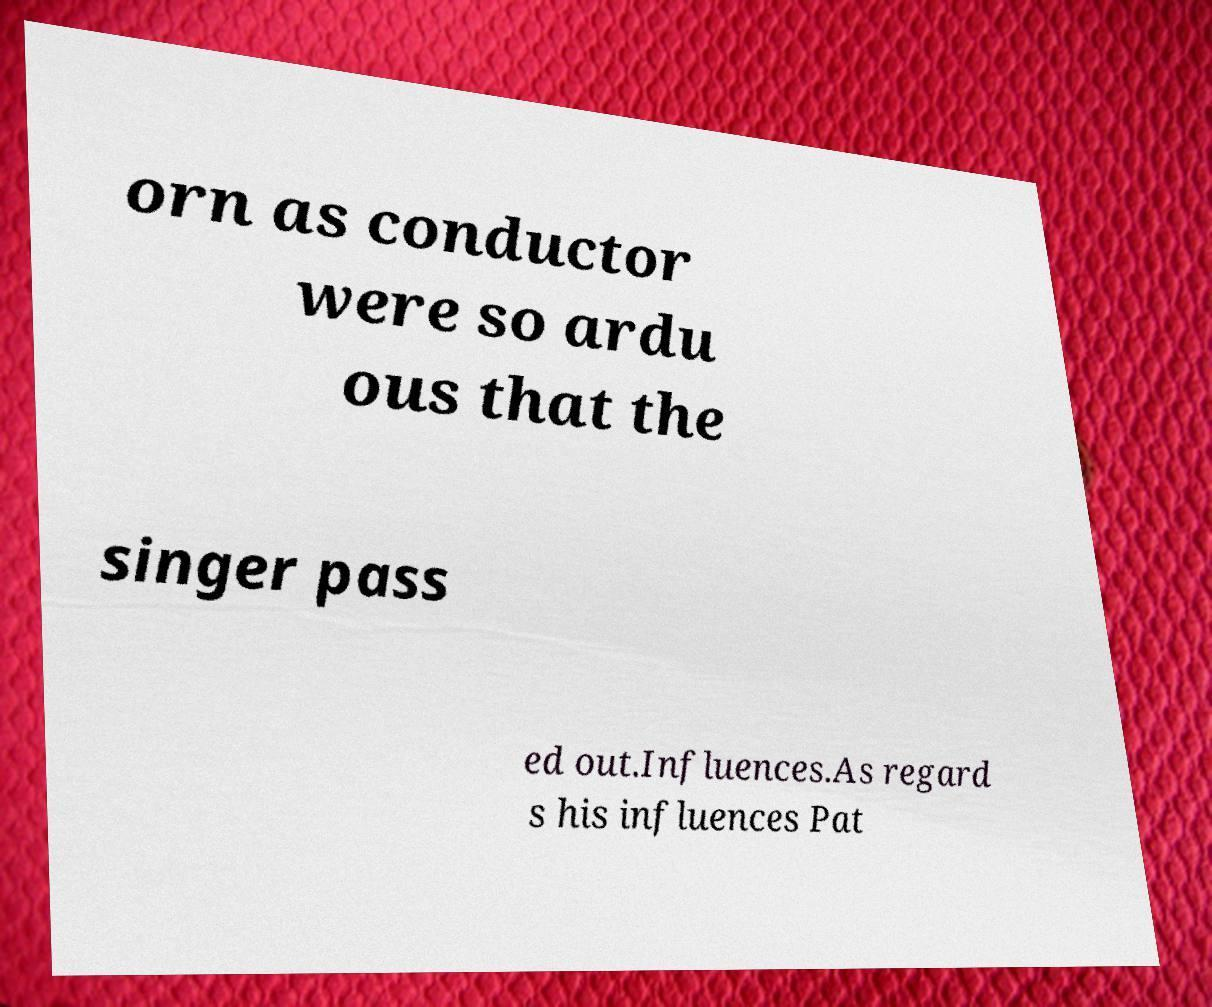Can you read and provide the text displayed in the image?This photo seems to have some interesting text. Can you extract and type it out for me? orn as conductor were so ardu ous that the singer pass ed out.Influences.As regard s his influences Pat 